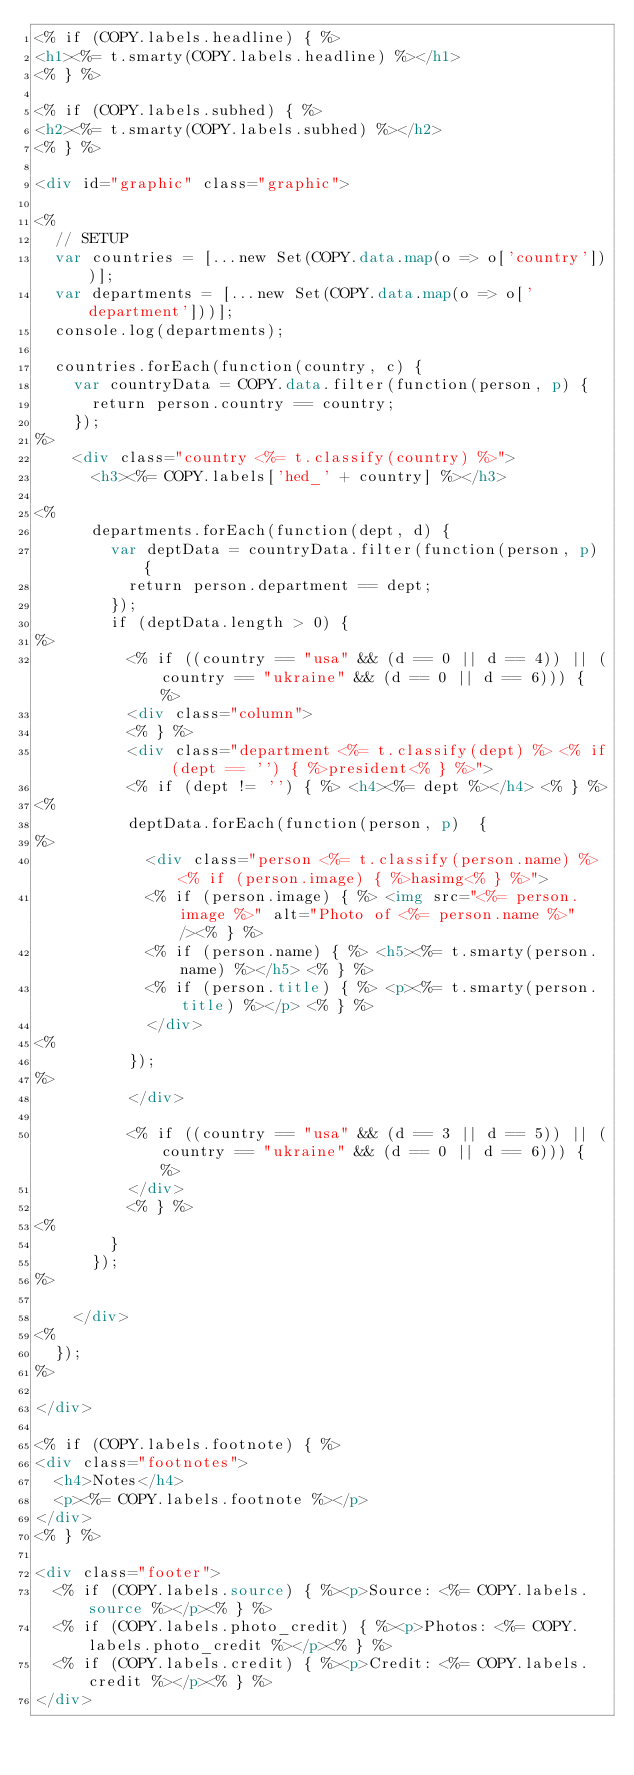<code> <loc_0><loc_0><loc_500><loc_500><_HTML_><% if (COPY.labels.headline) { %>
<h1><%= t.smarty(COPY.labels.headline) %></h1>
<% } %>

<% if (COPY.labels.subhed) { %>
<h2><%= t.smarty(COPY.labels.subhed) %></h2>
<% } %>

<div id="graphic" class="graphic">

<%
  // SETUP
  var countries = [...new Set(COPY.data.map(o => o['country']))];
  var departments = [...new Set(COPY.data.map(o => o['department']))];
  console.log(departments);

  countries.forEach(function(country, c) {
    var countryData = COPY.data.filter(function(person, p) {
      return person.country == country;
    });
%>
    <div class="country <%= t.classify(country) %>">
      <h3><%= COPY.labels['hed_' + country] %></h3>

<%
      departments.forEach(function(dept, d) {
        var deptData = countryData.filter(function(person, p) {
          return person.department == dept;
        });
        if (deptData.length > 0) {
%>
          <% if ((country == "usa" && (d == 0 || d == 4)) || (country == "ukraine" && (d == 0 || d == 6))) { %>
          <div class="column">
          <% } %>
          <div class="department <%= t.classify(dept) %> <% if (dept == '') { %>president<% } %>">
          <% if (dept != '') { %> <h4><%= dept %></h4> <% } %>
<%
          deptData.forEach(function(person, p)  {
%>
            <div class="person <%= t.classify(person.name) %> <% if (person.image) { %>hasimg<% } %>">
            <% if (person.image) { %> <img src="<%= person.image %>" alt="Photo of <%= person.name %>" /><% } %>
            <% if (person.name) { %> <h5><%= t.smarty(person.name) %></h5> <% } %>
            <% if (person.title) { %> <p><%= t.smarty(person.title) %></p> <% } %>
            </div>
<%
          });
%>
          </div>

          <% if ((country == "usa" && (d == 3 || d == 5)) || (country == "ukraine" && (d == 0 || d == 6))) { %>
          </div>
          <% } %>
<%
        }
      });
%>

    </div>
<%
  });
%>

</div>

<% if (COPY.labels.footnote) { %>
<div class="footnotes">
  <h4>Notes</h4>
  <p><%= COPY.labels.footnote %></p>
</div>
<% } %>

<div class="footer">
  <% if (COPY.labels.source) { %><p>Source: <%= COPY.labels.source %></p><% } %>
  <% if (COPY.labels.photo_credit) { %><p>Photos: <%= COPY.labels.photo_credit %></p><% } %>
  <% if (COPY.labels.credit) { %><p>Credit: <%= COPY.labels.credit %></p><% } %>
</div>
</code> 